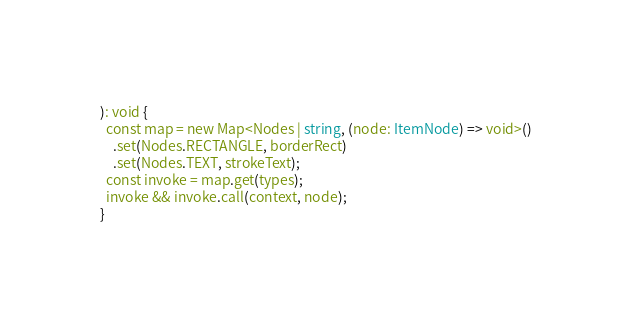Convert code to text. <code><loc_0><loc_0><loc_500><loc_500><_TypeScript_>): void {
  const map = new Map<Nodes | string, (node: ItemNode) => void>()
    .set(Nodes.RECTANGLE, borderRect)
    .set(Nodes.TEXT, strokeText);
  const invoke = map.get(types);
  invoke && invoke.call(context, node);
}
</code> 